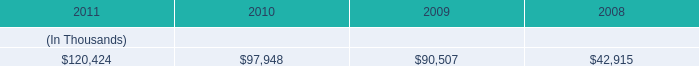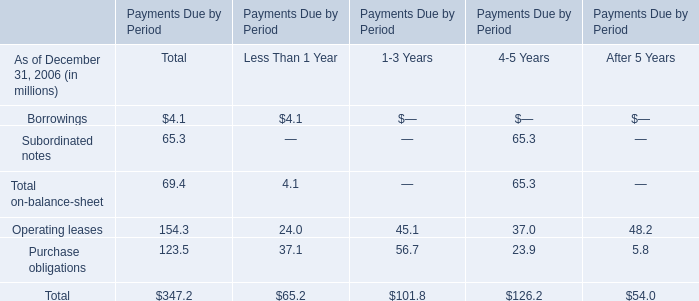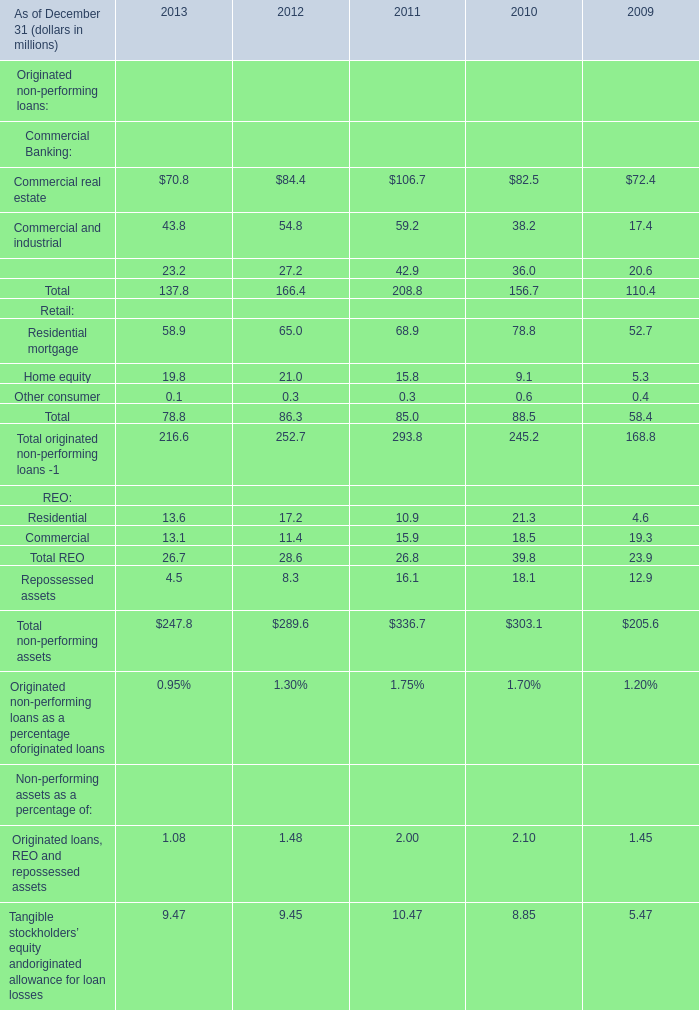what will be the yearly interest expense for system energy vie for the note issued in 2012 , ( in millions ) ? 
Computations: (50 - 4.02%)
Answer: 49.9598. 